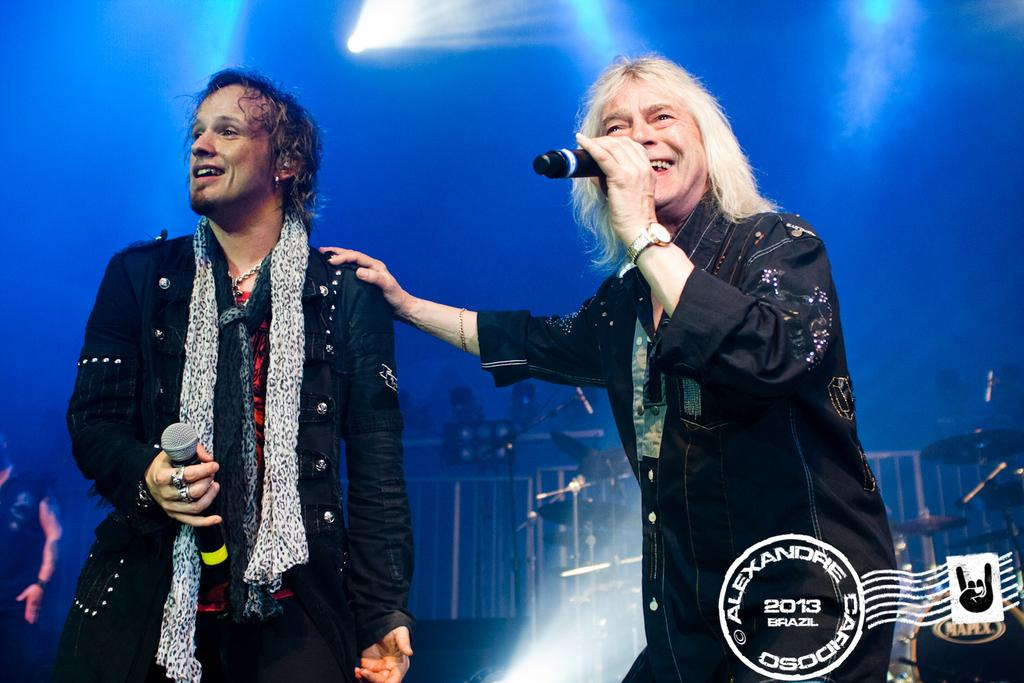<image>
Offer a succinct explanation of the picture presented. Two rock stars were documented while in Brazil in 2013. 